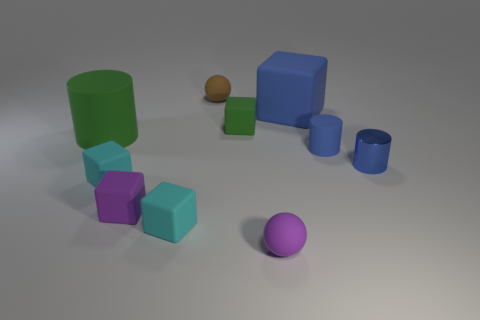Subtract all green blocks. How many blocks are left? 4 Subtract all gray balls. How many blue cylinders are left? 2 Subtract all cyan blocks. How many blocks are left? 3 Subtract all balls. How many objects are left? 8 Subtract all purple spheres. Subtract all big blue blocks. How many objects are left? 8 Add 1 tiny blue cylinders. How many tiny blue cylinders are left? 3 Add 4 tiny blue objects. How many tiny blue objects exist? 6 Subtract 1 blue blocks. How many objects are left? 9 Subtract all green cylinders. Subtract all green cubes. How many cylinders are left? 2 